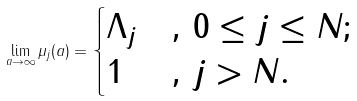Convert formula to latex. <formula><loc_0><loc_0><loc_500><loc_500>\lim _ { a \to \infty } \mu _ { j } ( a ) = \begin{cases} \Lambda _ { j } & , \, 0 \leq j \leq N ; \\ 1 & , \, j > N . \end{cases}</formula> 